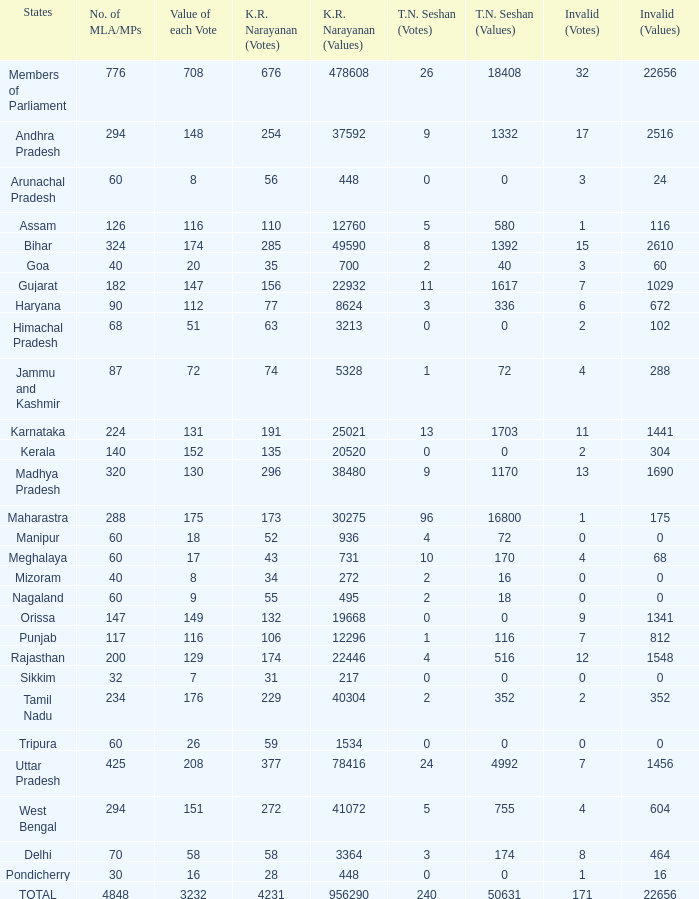For kr values equal to 478608, how many tn seshan values can be identified? 1.0. 